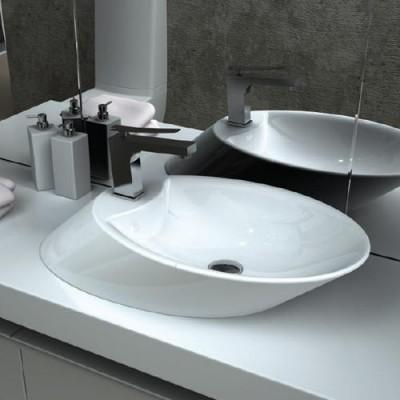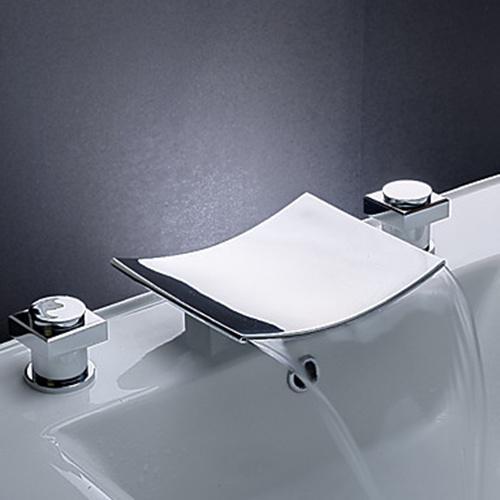The first image is the image on the left, the second image is the image on the right. Examine the images to the left and right. Is the description "The left and right image contains the same number of oval sinks." accurate? Answer yes or no. No. The first image is the image on the left, the second image is the image on the right. For the images displayed, is the sentence "In exactly one image water is pouring from the faucet." factually correct? Answer yes or no. Yes. 